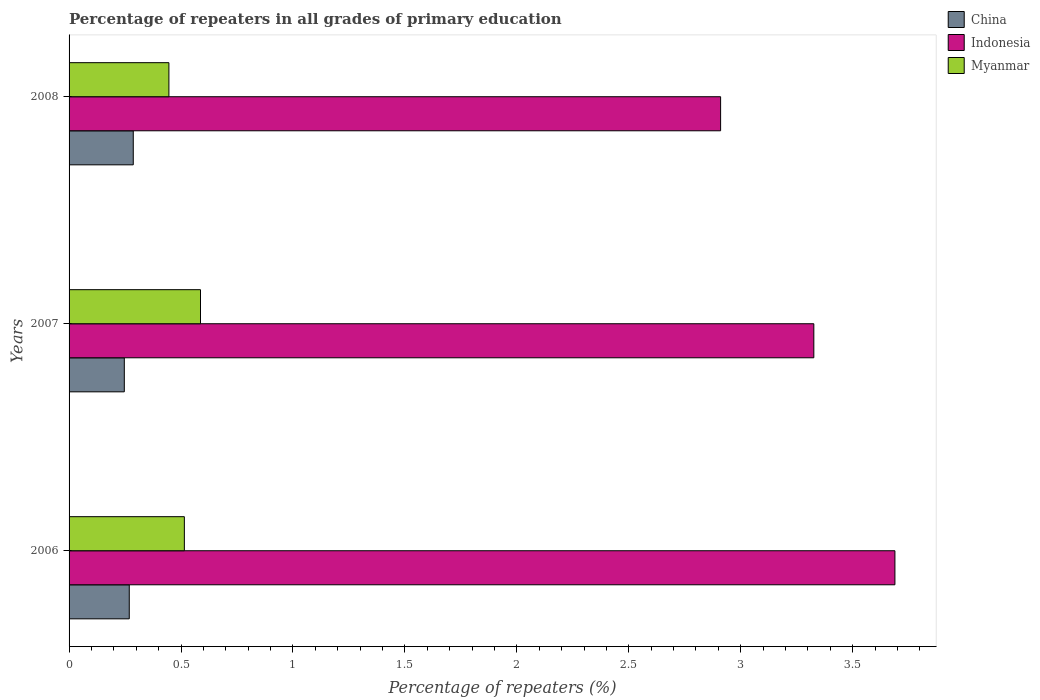How many different coloured bars are there?
Your answer should be compact. 3. How many bars are there on the 2nd tick from the top?
Offer a terse response. 3. How many bars are there on the 2nd tick from the bottom?
Offer a very short reply. 3. What is the label of the 3rd group of bars from the top?
Keep it short and to the point. 2006. In how many cases, is the number of bars for a given year not equal to the number of legend labels?
Offer a terse response. 0. What is the percentage of repeaters in Indonesia in 2007?
Offer a very short reply. 3.33. Across all years, what is the maximum percentage of repeaters in China?
Make the answer very short. 0.29. Across all years, what is the minimum percentage of repeaters in Indonesia?
Keep it short and to the point. 2.91. In which year was the percentage of repeaters in Indonesia maximum?
Offer a very short reply. 2006. In which year was the percentage of repeaters in Myanmar minimum?
Provide a succinct answer. 2008. What is the total percentage of repeaters in Myanmar in the graph?
Your answer should be very brief. 1.55. What is the difference between the percentage of repeaters in Myanmar in 2006 and that in 2007?
Offer a terse response. -0.07. What is the difference between the percentage of repeaters in Myanmar in 2008 and the percentage of repeaters in Indonesia in 2007?
Give a very brief answer. -2.88. What is the average percentage of repeaters in Myanmar per year?
Make the answer very short. 0.52. In the year 2006, what is the difference between the percentage of repeaters in Indonesia and percentage of repeaters in China?
Provide a succinct answer. 3.42. What is the ratio of the percentage of repeaters in China in 2007 to that in 2008?
Offer a very short reply. 0.86. What is the difference between the highest and the second highest percentage of repeaters in Indonesia?
Your response must be concise. 0.36. What is the difference between the highest and the lowest percentage of repeaters in China?
Your response must be concise. 0.04. What does the 3rd bar from the bottom in 2006 represents?
Offer a terse response. Myanmar. Is it the case that in every year, the sum of the percentage of repeaters in Myanmar and percentage of repeaters in China is greater than the percentage of repeaters in Indonesia?
Give a very brief answer. No. Are all the bars in the graph horizontal?
Provide a succinct answer. Yes. Does the graph contain any zero values?
Your response must be concise. No. Does the graph contain grids?
Your response must be concise. No. Where does the legend appear in the graph?
Your answer should be compact. Top right. How are the legend labels stacked?
Keep it short and to the point. Vertical. What is the title of the graph?
Your answer should be very brief. Percentage of repeaters in all grades of primary education. Does "Pacific island small states" appear as one of the legend labels in the graph?
Ensure brevity in your answer.  No. What is the label or title of the X-axis?
Your response must be concise. Percentage of repeaters (%). What is the Percentage of repeaters (%) in China in 2006?
Offer a terse response. 0.27. What is the Percentage of repeaters (%) of Indonesia in 2006?
Provide a short and direct response. 3.69. What is the Percentage of repeaters (%) in Myanmar in 2006?
Provide a succinct answer. 0.51. What is the Percentage of repeaters (%) of China in 2007?
Provide a short and direct response. 0.25. What is the Percentage of repeaters (%) of Indonesia in 2007?
Ensure brevity in your answer.  3.33. What is the Percentage of repeaters (%) in Myanmar in 2007?
Provide a succinct answer. 0.59. What is the Percentage of repeaters (%) in China in 2008?
Your answer should be compact. 0.29. What is the Percentage of repeaters (%) of Indonesia in 2008?
Your answer should be very brief. 2.91. What is the Percentage of repeaters (%) of Myanmar in 2008?
Provide a short and direct response. 0.45. Across all years, what is the maximum Percentage of repeaters (%) of China?
Provide a short and direct response. 0.29. Across all years, what is the maximum Percentage of repeaters (%) of Indonesia?
Your answer should be very brief. 3.69. Across all years, what is the maximum Percentage of repeaters (%) of Myanmar?
Offer a very short reply. 0.59. Across all years, what is the minimum Percentage of repeaters (%) of China?
Your answer should be compact. 0.25. Across all years, what is the minimum Percentage of repeaters (%) in Indonesia?
Your response must be concise. 2.91. Across all years, what is the minimum Percentage of repeaters (%) of Myanmar?
Offer a terse response. 0.45. What is the total Percentage of repeaters (%) of China in the graph?
Provide a short and direct response. 0.8. What is the total Percentage of repeaters (%) in Indonesia in the graph?
Give a very brief answer. 9.93. What is the total Percentage of repeaters (%) in Myanmar in the graph?
Your answer should be compact. 1.55. What is the difference between the Percentage of repeaters (%) in China in 2006 and that in 2007?
Offer a very short reply. 0.02. What is the difference between the Percentage of repeaters (%) of Indonesia in 2006 and that in 2007?
Provide a succinct answer. 0.36. What is the difference between the Percentage of repeaters (%) of Myanmar in 2006 and that in 2007?
Ensure brevity in your answer.  -0.07. What is the difference between the Percentage of repeaters (%) of China in 2006 and that in 2008?
Your response must be concise. -0.02. What is the difference between the Percentage of repeaters (%) of Indonesia in 2006 and that in 2008?
Your answer should be very brief. 0.78. What is the difference between the Percentage of repeaters (%) in Myanmar in 2006 and that in 2008?
Offer a terse response. 0.07. What is the difference between the Percentage of repeaters (%) in China in 2007 and that in 2008?
Keep it short and to the point. -0.04. What is the difference between the Percentage of repeaters (%) of Indonesia in 2007 and that in 2008?
Make the answer very short. 0.42. What is the difference between the Percentage of repeaters (%) in Myanmar in 2007 and that in 2008?
Provide a short and direct response. 0.14. What is the difference between the Percentage of repeaters (%) in China in 2006 and the Percentage of repeaters (%) in Indonesia in 2007?
Offer a very short reply. -3.06. What is the difference between the Percentage of repeaters (%) of China in 2006 and the Percentage of repeaters (%) of Myanmar in 2007?
Make the answer very short. -0.32. What is the difference between the Percentage of repeaters (%) of Indonesia in 2006 and the Percentage of repeaters (%) of Myanmar in 2007?
Keep it short and to the point. 3.1. What is the difference between the Percentage of repeaters (%) in China in 2006 and the Percentage of repeaters (%) in Indonesia in 2008?
Provide a short and direct response. -2.64. What is the difference between the Percentage of repeaters (%) in China in 2006 and the Percentage of repeaters (%) in Myanmar in 2008?
Your answer should be very brief. -0.18. What is the difference between the Percentage of repeaters (%) of Indonesia in 2006 and the Percentage of repeaters (%) of Myanmar in 2008?
Give a very brief answer. 3.24. What is the difference between the Percentage of repeaters (%) of China in 2007 and the Percentage of repeaters (%) of Indonesia in 2008?
Your answer should be compact. -2.66. What is the difference between the Percentage of repeaters (%) in China in 2007 and the Percentage of repeaters (%) in Myanmar in 2008?
Provide a short and direct response. -0.2. What is the difference between the Percentage of repeaters (%) in Indonesia in 2007 and the Percentage of repeaters (%) in Myanmar in 2008?
Keep it short and to the point. 2.88. What is the average Percentage of repeaters (%) of China per year?
Your answer should be very brief. 0.27. What is the average Percentage of repeaters (%) of Indonesia per year?
Your response must be concise. 3.31. What is the average Percentage of repeaters (%) in Myanmar per year?
Provide a succinct answer. 0.52. In the year 2006, what is the difference between the Percentage of repeaters (%) of China and Percentage of repeaters (%) of Indonesia?
Provide a short and direct response. -3.42. In the year 2006, what is the difference between the Percentage of repeaters (%) in China and Percentage of repeaters (%) in Myanmar?
Offer a terse response. -0.25. In the year 2006, what is the difference between the Percentage of repeaters (%) of Indonesia and Percentage of repeaters (%) of Myanmar?
Give a very brief answer. 3.17. In the year 2007, what is the difference between the Percentage of repeaters (%) in China and Percentage of repeaters (%) in Indonesia?
Your answer should be compact. -3.08. In the year 2007, what is the difference between the Percentage of repeaters (%) of China and Percentage of repeaters (%) of Myanmar?
Make the answer very short. -0.34. In the year 2007, what is the difference between the Percentage of repeaters (%) of Indonesia and Percentage of repeaters (%) of Myanmar?
Make the answer very short. 2.74. In the year 2008, what is the difference between the Percentage of repeaters (%) of China and Percentage of repeaters (%) of Indonesia?
Offer a very short reply. -2.62. In the year 2008, what is the difference between the Percentage of repeaters (%) of China and Percentage of repeaters (%) of Myanmar?
Offer a terse response. -0.16. In the year 2008, what is the difference between the Percentage of repeaters (%) of Indonesia and Percentage of repeaters (%) of Myanmar?
Provide a short and direct response. 2.46. What is the ratio of the Percentage of repeaters (%) in China in 2006 to that in 2007?
Your answer should be compact. 1.09. What is the ratio of the Percentage of repeaters (%) in Indonesia in 2006 to that in 2007?
Provide a succinct answer. 1.11. What is the ratio of the Percentage of repeaters (%) of Myanmar in 2006 to that in 2007?
Offer a terse response. 0.88. What is the ratio of the Percentage of repeaters (%) of China in 2006 to that in 2008?
Your answer should be very brief. 0.94. What is the ratio of the Percentage of repeaters (%) in Indonesia in 2006 to that in 2008?
Provide a short and direct response. 1.27. What is the ratio of the Percentage of repeaters (%) in Myanmar in 2006 to that in 2008?
Provide a short and direct response. 1.15. What is the ratio of the Percentage of repeaters (%) of China in 2007 to that in 2008?
Offer a terse response. 0.86. What is the ratio of the Percentage of repeaters (%) in Indonesia in 2007 to that in 2008?
Offer a terse response. 1.14. What is the ratio of the Percentage of repeaters (%) in Myanmar in 2007 to that in 2008?
Provide a short and direct response. 1.32. What is the difference between the highest and the second highest Percentage of repeaters (%) in China?
Offer a terse response. 0.02. What is the difference between the highest and the second highest Percentage of repeaters (%) of Indonesia?
Provide a short and direct response. 0.36. What is the difference between the highest and the second highest Percentage of repeaters (%) in Myanmar?
Provide a short and direct response. 0.07. What is the difference between the highest and the lowest Percentage of repeaters (%) in Indonesia?
Keep it short and to the point. 0.78. What is the difference between the highest and the lowest Percentage of repeaters (%) of Myanmar?
Your response must be concise. 0.14. 